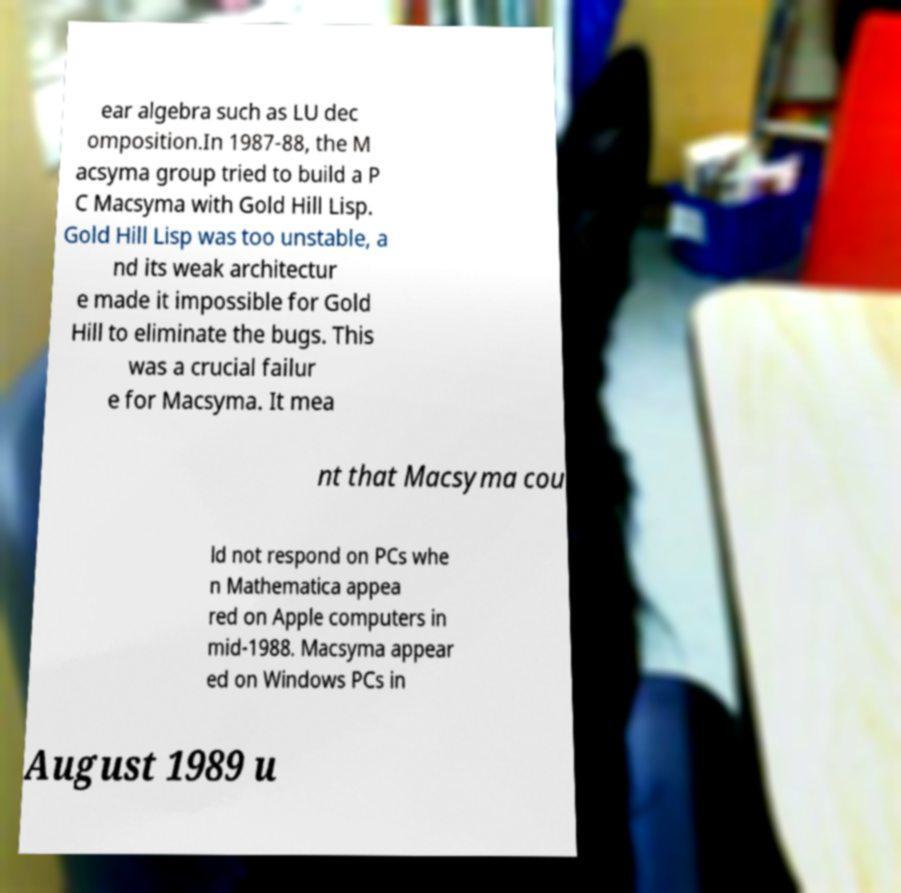I need the written content from this picture converted into text. Can you do that? ear algebra such as LU dec omposition.In 1987-88, the M acsyma group tried to build a P C Macsyma with Gold Hill Lisp. Gold Hill Lisp was too unstable, a nd its weak architectur e made it impossible for Gold Hill to eliminate the bugs. This was a crucial failur e for Macsyma. It mea nt that Macsyma cou ld not respond on PCs whe n Mathematica appea red on Apple computers in mid-1988. Macsyma appear ed on Windows PCs in August 1989 u 